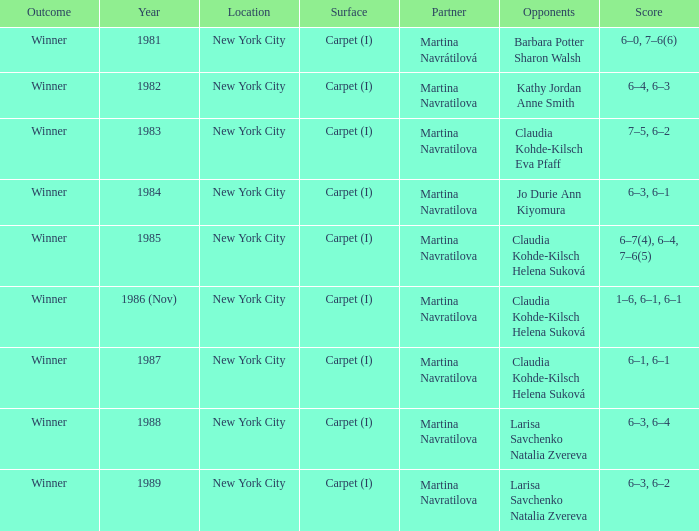Who were all the rival competitors in 1984? Jo Durie Ann Kiyomura. 